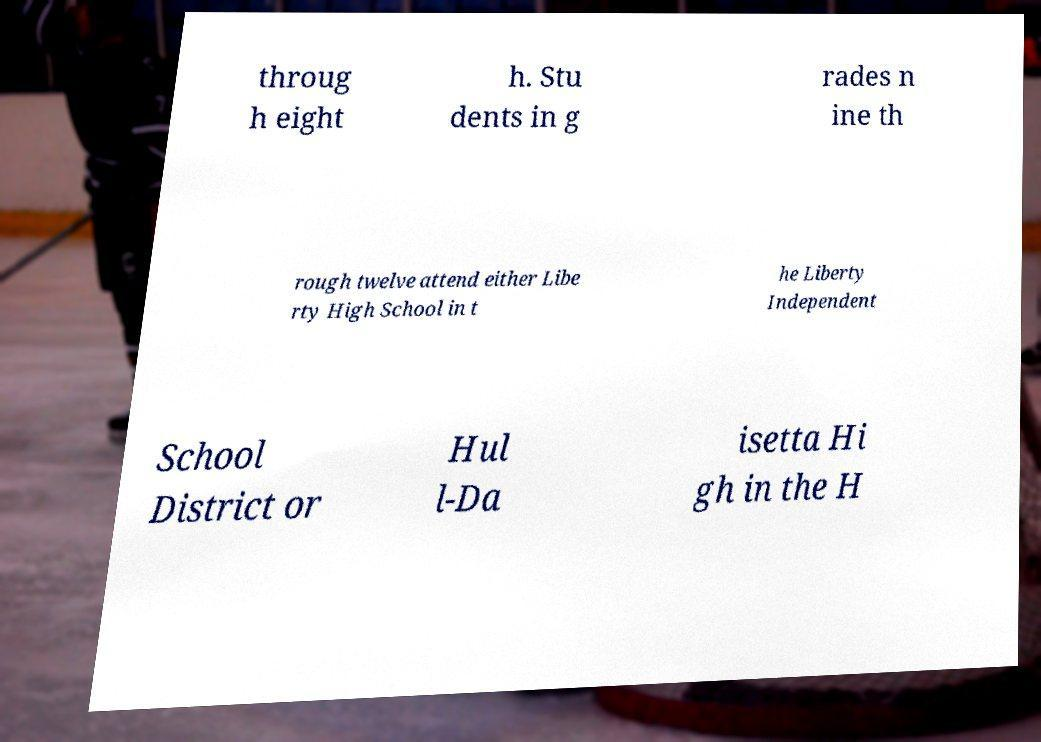Please read and relay the text visible in this image. What does it say? throug h eight h. Stu dents in g rades n ine th rough twelve attend either Libe rty High School in t he Liberty Independent School District or Hul l-Da isetta Hi gh in the H 